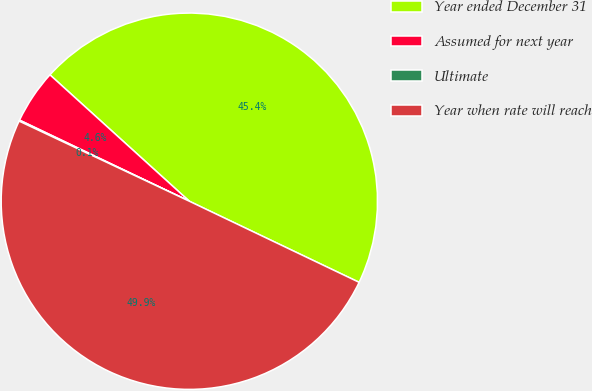Convert chart. <chart><loc_0><loc_0><loc_500><loc_500><pie_chart><fcel>Year ended December 31<fcel>Assumed for next year<fcel>Ultimate<fcel>Year when rate will reach<nl><fcel>45.37%<fcel>4.63%<fcel>0.09%<fcel>49.91%<nl></chart> 